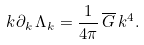Convert formula to latex. <formula><loc_0><loc_0><loc_500><loc_500>k \partial _ { k } \, \Lambda _ { k } & = \frac { 1 } { 4 \pi } \, \overline { G } \, k ^ { 4 } .</formula> 